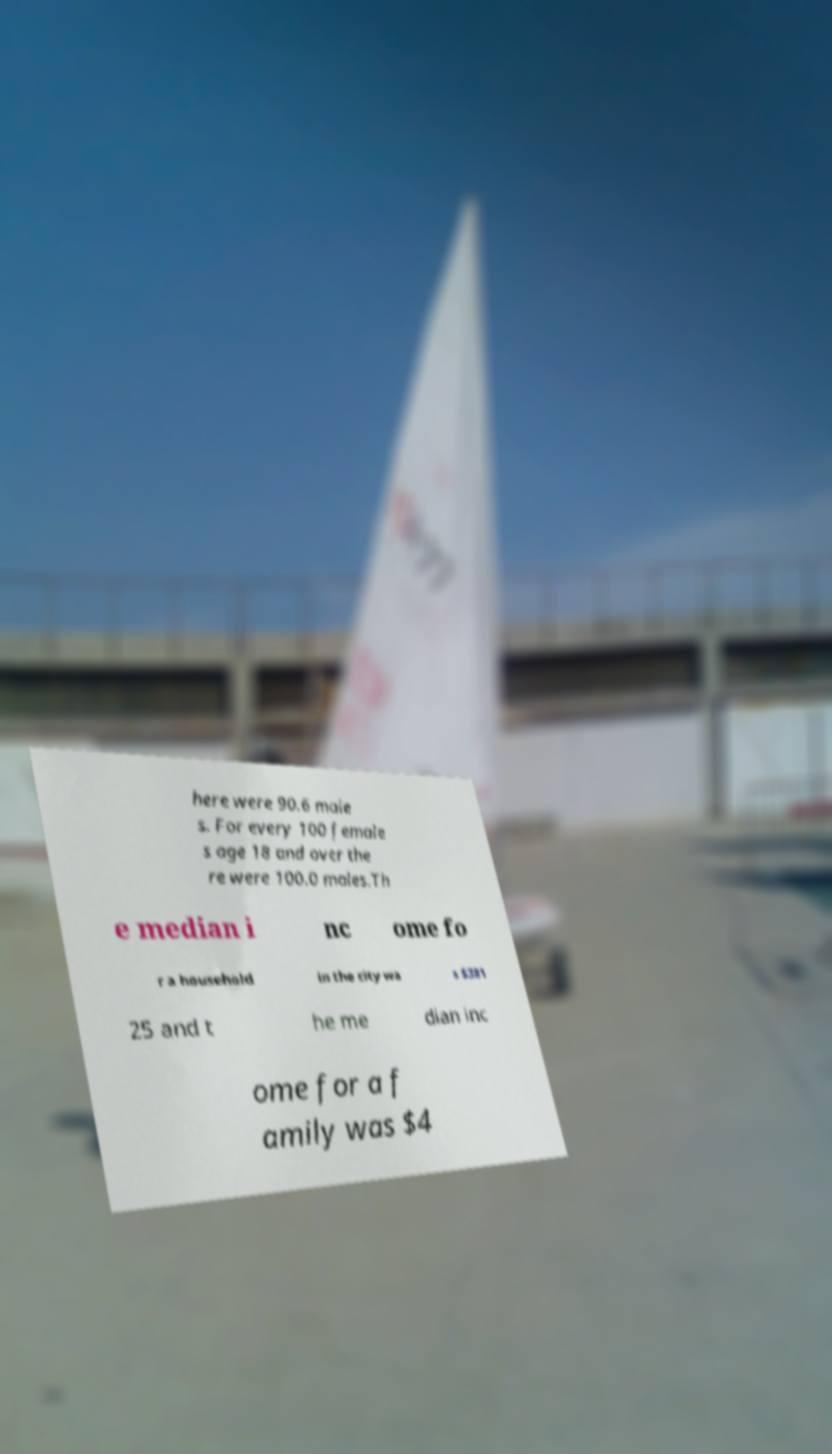Can you accurately transcribe the text from the provided image for me? here were 90.6 male s. For every 100 female s age 18 and over the re were 100.0 males.Th e median i nc ome fo r a household in the city wa s $381 25 and t he me dian inc ome for a f amily was $4 